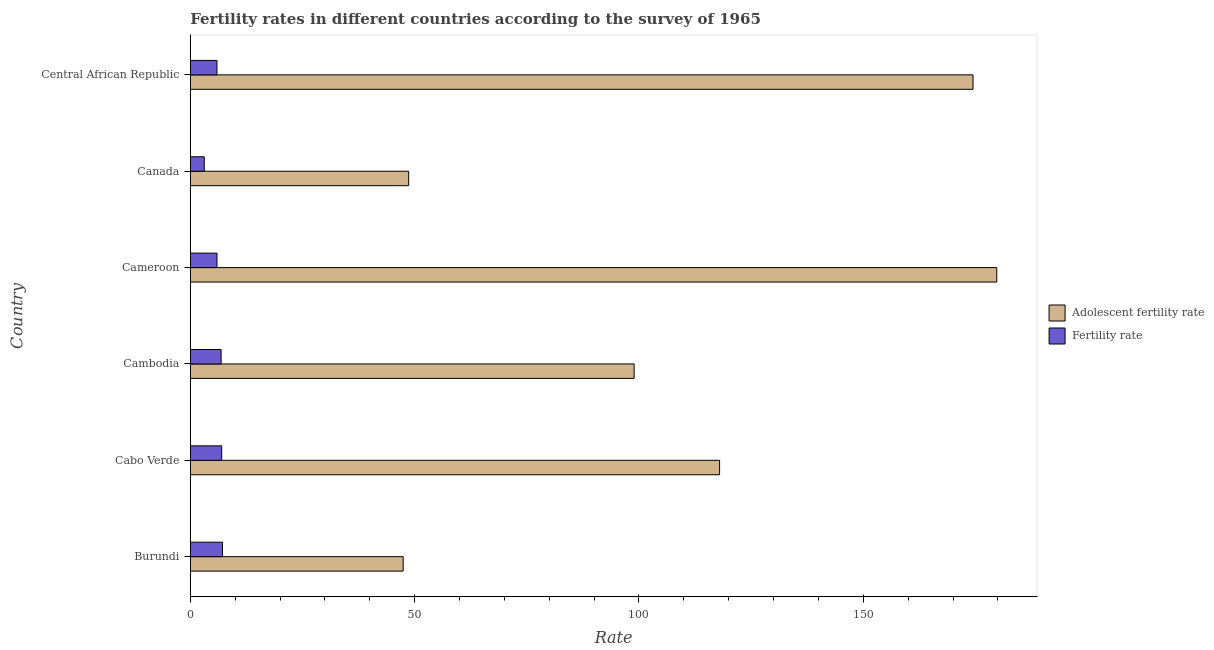How many different coloured bars are there?
Offer a terse response. 2. Are the number of bars on each tick of the Y-axis equal?
Ensure brevity in your answer.  Yes. How many bars are there on the 2nd tick from the bottom?
Make the answer very short. 2. In how many cases, is the number of bars for a given country not equal to the number of legend labels?
Your answer should be compact. 0. What is the adolescent fertility rate in Burundi?
Your response must be concise. 47.45. Across all countries, what is the maximum fertility rate?
Ensure brevity in your answer.  7.18. Across all countries, what is the minimum adolescent fertility rate?
Keep it short and to the point. 47.45. In which country was the fertility rate maximum?
Offer a very short reply. Burundi. In which country was the adolescent fertility rate minimum?
Offer a very short reply. Burundi. What is the total fertility rate in the graph?
Ensure brevity in your answer.  36.04. What is the difference between the fertility rate in Cabo Verde and that in Cameroon?
Make the answer very short. 1.04. What is the difference between the fertility rate in Cameroon and the adolescent fertility rate in Cabo Verde?
Provide a succinct answer. -112.03. What is the average adolescent fertility rate per country?
Provide a succinct answer. 111.21. What is the difference between the adolescent fertility rate and fertility rate in Burundi?
Your response must be concise. 40.27. In how many countries, is the adolescent fertility rate greater than 10 ?
Your answer should be very brief. 6. What is the ratio of the fertility rate in Burundi to that in Cabo Verde?
Give a very brief answer. 1.03. Is the fertility rate in Burundi less than that in Central African Republic?
Provide a short and direct response. No. What is the difference between the highest and the second highest adolescent fertility rate?
Your response must be concise. 5.29. What is the difference between the highest and the lowest fertility rate?
Ensure brevity in your answer.  4.06. What does the 1st bar from the top in Burundi represents?
Ensure brevity in your answer.  Fertility rate. What does the 2nd bar from the bottom in Canada represents?
Keep it short and to the point. Fertility rate. Does the graph contain any zero values?
Provide a succinct answer. No. Does the graph contain grids?
Give a very brief answer. No. Where does the legend appear in the graph?
Provide a succinct answer. Center right. How many legend labels are there?
Your response must be concise. 2. What is the title of the graph?
Ensure brevity in your answer.  Fertility rates in different countries according to the survey of 1965. Does "Official aid received" appear as one of the legend labels in the graph?
Offer a very short reply. No. What is the label or title of the X-axis?
Your answer should be very brief. Rate. What is the Rate in Adolescent fertility rate in Burundi?
Your answer should be compact. 47.45. What is the Rate of Fertility rate in Burundi?
Provide a short and direct response. 7.18. What is the Rate in Adolescent fertility rate in Cabo Verde?
Your answer should be very brief. 117.98. What is the Rate of Fertility rate in Cabo Verde?
Your answer should be compact. 6.99. What is the Rate in Adolescent fertility rate in Cambodia?
Offer a terse response. 98.93. What is the Rate in Fertility rate in Cambodia?
Offer a terse response. 6.87. What is the Rate in Adolescent fertility rate in Cameroon?
Provide a short and direct response. 179.75. What is the Rate of Fertility rate in Cameroon?
Make the answer very short. 5.95. What is the Rate of Adolescent fertility rate in Canada?
Keep it short and to the point. 48.67. What is the Rate in Fertility rate in Canada?
Give a very brief answer. 3.12. What is the Rate of Adolescent fertility rate in Central African Republic?
Your response must be concise. 174.46. What is the Rate in Fertility rate in Central African Republic?
Provide a short and direct response. 5.94. Across all countries, what is the maximum Rate in Adolescent fertility rate?
Offer a very short reply. 179.75. Across all countries, what is the maximum Rate of Fertility rate?
Offer a terse response. 7.18. Across all countries, what is the minimum Rate in Adolescent fertility rate?
Ensure brevity in your answer.  47.45. Across all countries, what is the minimum Rate of Fertility rate?
Keep it short and to the point. 3.12. What is the total Rate in Adolescent fertility rate in the graph?
Offer a very short reply. 667.24. What is the total Rate in Fertility rate in the graph?
Provide a short and direct response. 36.04. What is the difference between the Rate in Adolescent fertility rate in Burundi and that in Cabo Verde?
Offer a very short reply. -70.53. What is the difference between the Rate of Fertility rate in Burundi and that in Cabo Verde?
Give a very brief answer. 0.19. What is the difference between the Rate of Adolescent fertility rate in Burundi and that in Cambodia?
Your answer should be compact. -51.48. What is the difference between the Rate in Fertility rate in Burundi and that in Cambodia?
Keep it short and to the point. 0.31. What is the difference between the Rate in Adolescent fertility rate in Burundi and that in Cameroon?
Provide a short and direct response. -132.3. What is the difference between the Rate in Fertility rate in Burundi and that in Cameroon?
Give a very brief answer. 1.23. What is the difference between the Rate in Adolescent fertility rate in Burundi and that in Canada?
Offer a very short reply. -1.22. What is the difference between the Rate of Fertility rate in Burundi and that in Canada?
Offer a terse response. 4.06. What is the difference between the Rate in Adolescent fertility rate in Burundi and that in Central African Republic?
Provide a succinct answer. -127.01. What is the difference between the Rate of Fertility rate in Burundi and that in Central African Republic?
Ensure brevity in your answer.  1.24. What is the difference between the Rate of Adolescent fertility rate in Cabo Verde and that in Cambodia?
Your answer should be compact. 19.05. What is the difference between the Rate of Fertility rate in Cabo Verde and that in Cambodia?
Your answer should be compact. 0.12. What is the difference between the Rate of Adolescent fertility rate in Cabo Verde and that in Cameroon?
Give a very brief answer. -61.78. What is the difference between the Rate of Fertility rate in Cabo Verde and that in Cameroon?
Keep it short and to the point. 1.04. What is the difference between the Rate in Adolescent fertility rate in Cabo Verde and that in Canada?
Give a very brief answer. 69.3. What is the difference between the Rate of Fertility rate in Cabo Verde and that in Canada?
Offer a terse response. 3.88. What is the difference between the Rate of Adolescent fertility rate in Cabo Verde and that in Central African Republic?
Your answer should be very brief. -56.49. What is the difference between the Rate of Fertility rate in Cabo Verde and that in Central African Republic?
Ensure brevity in your answer.  1.06. What is the difference between the Rate of Adolescent fertility rate in Cambodia and that in Cameroon?
Give a very brief answer. -80.82. What is the difference between the Rate of Fertility rate in Cambodia and that in Cameroon?
Your answer should be compact. 0.92. What is the difference between the Rate in Adolescent fertility rate in Cambodia and that in Canada?
Your answer should be very brief. 50.26. What is the difference between the Rate of Fertility rate in Cambodia and that in Canada?
Your response must be concise. 3.75. What is the difference between the Rate in Adolescent fertility rate in Cambodia and that in Central African Republic?
Ensure brevity in your answer.  -75.53. What is the difference between the Rate of Adolescent fertility rate in Cameroon and that in Canada?
Provide a succinct answer. 131.08. What is the difference between the Rate in Fertility rate in Cameroon and that in Canada?
Offer a very short reply. 2.83. What is the difference between the Rate of Adolescent fertility rate in Cameroon and that in Central African Republic?
Offer a terse response. 5.29. What is the difference between the Rate in Fertility rate in Cameroon and that in Central African Republic?
Your answer should be compact. 0.01. What is the difference between the Rate in Adolescent fertility rate in Canada and that in Central African Republic?
Give a very brief answer. -125.79. What is the difference between the Rate in Fertility rate in Canada and that in Central African Republic?
Provide a short and direct response. -2.82. What is the difference between the Rate of Adolescent fertility rate in Burundi and the Rate of Fertility rate in Cabo Verde?
Give a very brief answer. 40.46. What is the difference between the Rate of Adolescent fertility rate in Burundi and the Rate of Fertility rate in Cambodia?
Your answer should be compact. 40.58. What is the difference between the Rate in Adolescent fertility rate in Burundi and the Rate in Fertility rate in Cameroon?
Ensure brevity in your answer.  41.5. What is the difference between the Rate of Adolescent fertility rate in Burundi and the Rate of Fertility rate in Canada?
Give a very brief answer. 44.33. What is the difference between the Rate of Adolescent fertility rate in Burundi and the Rate of Fertility rate in Central African Republic?
Offer a terse response. 41.51. What is the difference between the Rate in Adolescent fertility rate in Cabo Verde and the Rate in Fertility rate in Cambodia?
Your answer should be compact. 111.11. What is the difference between the Rate in Adolescent fertility rate in Cabo Verde and the Rate in Fertility rate in Cameroon?
Make the answer very short. 112.03. What is the difference between the Rate of Adolescent fertility rate in Cabo Verde and the Rate of Fertility rate in Canada?
Give a very brief answer. 114.86. What is the difference between the Rate of Adolescent fertility rate in Cabo Verde and the Rate of Fertility rate in Central African Republic?
Ensure brevity in your answer.  112.04. What is the difference between the Rate in Adolescent fertility rate in Cambodia and the Rate in Fertility rate in Cameroon?
Provide a succinct answer. 92.98. What is the difference between the Rate in Adolescent fertility rate in Cambodia and the Rate in Fertility rate in Canada?
Give a very brief answer. 95.81. What is the difference between the Rate of Adolescent fertility rate in Cambodia and the Rate of Fertility rate in Central African Republic?
Offer a terse response. 92.99. What is the difference between the Rate in Adolescent fertility rate in Cameroon and the Rate in Fertility rate in Canada?
Give a very brief answer. 176.64. What is the difference between the Rate in Adolescent fertility rate in Cameroon and the Rate in Fertility rate in Central African Republic?
Keep it short and to the point. 173.81. What is the difference between the Rate of Adolescent fertility rate in Canada and the Rate of Fertility rate in Central African Republic?
Give a very brief answer. 42.74. What is the average Rate of Adolescent fertility rate per country?
Your response must be concise. 111.21. What is the average Rate in Fertility rate per country?
Your answer should be compact. 6.01. What is the difference between the Rate in Adolescent fertility rate and Rate in Fertility rate in Burundi?
Your response must be concise. 40.27. What is the difference between the Rate of Adolescent fertility rate and Rate of Fertility rate in Cabo Verde?
Offer a terse response. 110.98. What is the difference between the Rate in Adolescent fertility rate and Rate in Fertility rate in Cambodia?
Make the answer very short. 92.06. What is the difference between the Rate of Adolescent fertility rate and Rate of Fertility rate in Cameroon?
Offer a very short reply. 173.8. What is the difference between the Rate in Adolescent fertility rate and Rate in Fertility rate in Canada?
Offer a very short reply. 45.56. What is the difference between the Rate of Adolescent fertility rate and Rate of Fertility rate in Central African Republic?
Provide a short and direct response. 168.52. What is the ratio of the Rate of Adolescent fertility rate in Burundi to that in Cabo Verde?
Offer a very short reply. 0.4. What is the ratio of the Rate in Fertility rate in Burundi to that in Cabo Verde?
Keep it short and to the point. 1.03. What is the ratio of the Rate in Adolescent fertility rate in Burundi to that in Cambodia?
Keep it short and to the point. 0.48. What is the ratio of the Rate of Fertility rate in Burundi to that in Cambodia?
Your response must be concise. 1.05. What is the ratio of the Rate of Adolescent fertility rate in Burundi to that in Cameroon?
Keep it short and to the point. 0.26. What is the ratio of the Rate in Fertility rate in Burundi to that in Cameroon?
Give a very brief answer. 1.21. What is the ratio of the Rate in Adolescent fertility rate in Burundi to that in Canada?
Offer a terse response. 0.97. What is the ratio of the Rate of Fertility rate in Burundi to that in Canada?
Your response must be concise. 2.3. What is the ratio of the Rate in Adolescent fertility rate in Burundi to that in Central African Republic?
Offer a very short reply. 0.27. What is the ratio of the Rate in Fertility rate in Burundi to that in Central African Republic?
Your answer should be compact. 1.21. What is the ratio of the Rate in Adolescent fertility rate in Cabo Verde to that in Cambodia?
Keep it short and to the point. 1.19. What is the ratio of the Rate in Fertility rate in Cabo Verde to that in Cambodia?
Your answer should be very brief. 1.02. What is the ratio of the Rate of Adolescent fertility rate in Cabo Verde to that in Cameroon?
Your response must be concise. 0.66. What is the ratio of the Rate in Fertility rate in Cabo Verde to that in Cameroon?
Make the answer very short. 1.18. What is the ratio of the Rate in Adolescent fertility rate in Cabo Verde to that in Canada?
Provide a short and direct response. 2.42. What is the ratio of the Rate in Fertility rate in Cabo Verde to that in Canada?
Provide a succinct answer. 2.24. What is the ratio of the Rate of Adolescent fertility rate in Cabo Verde to that in Central African Republic?
Offer a very short reply. 0.68. What is the ratio of the Rate of Fertility rate in Cabo Verde to that in Central African Republic?
Provide a succinct answer. 1.18. What is the ratio of the Rate of Adolescent fertility rate in Cambodia to that in Cameroon?
Give a very brief answer. 0.55. What is the ratio of the Rate of Fertility rate in Cambodia to that in Cameroon?
Your answer should be compact. 1.15. What is the ratio of the Rate of Adolescent fertility rate in Cambodia to that in Canada?
Your answer should be very brief. 2.03. What is the ratio of the Rate in Fertility rate in Cambodia to that in Canada?
Provide a succinct answer. 2.2. What is the ratio of the Rate in Adolescent fertility rate in Cambodia to that in Central African Republic?
Your answer should be compact. 0.57. What is the ratio of the Rate of Fertility rate in Cambodia to that in Central African Republic?
Provide a succinct answer. 1.16. What is the ratio of the Rate of Adolescent fertility rate in Cameroon to that in Canada?
Ensure brevity in your answer.  3.69. What is the ratio of the Rate in Fertility rate in Cameroon to that in Canada?
Offer a very short reply. 1.91. What is the ratio of the Rate of Adolescent fertility rate in Cameroon to that in Central African Republic?
Provide a short and direct response. 1.03. What is the ratio of the Rate in Fertility rate in Cameroon to that in Central African Republic?
Ensure brevity in your answer.  1. What is the ratio of the Rate of Adolescent fertility rate in Canada to that in Central African Republic?
Give a very brief answer. 0.28. What is the ratio of the Rate of Fertility rate in Canada to that in Central African Republic?
Give a very brief answer. 0.52. What is the difference between the highest and the second highest Rate of Adolescent fertility rate?
Keep it short and to the point. 5.29. What is the difference between the highest and the second highest Rate in Fertility rate?
Offer a very short reply. 0.19. What is the difference between the highest and the lowest Rate in Adolescent fertility rate?
Offer a terse response. 132.3. What is the difference between the highest and the lowest Rate in Fertility rate?
Keep it short and to the point. 4.06. 